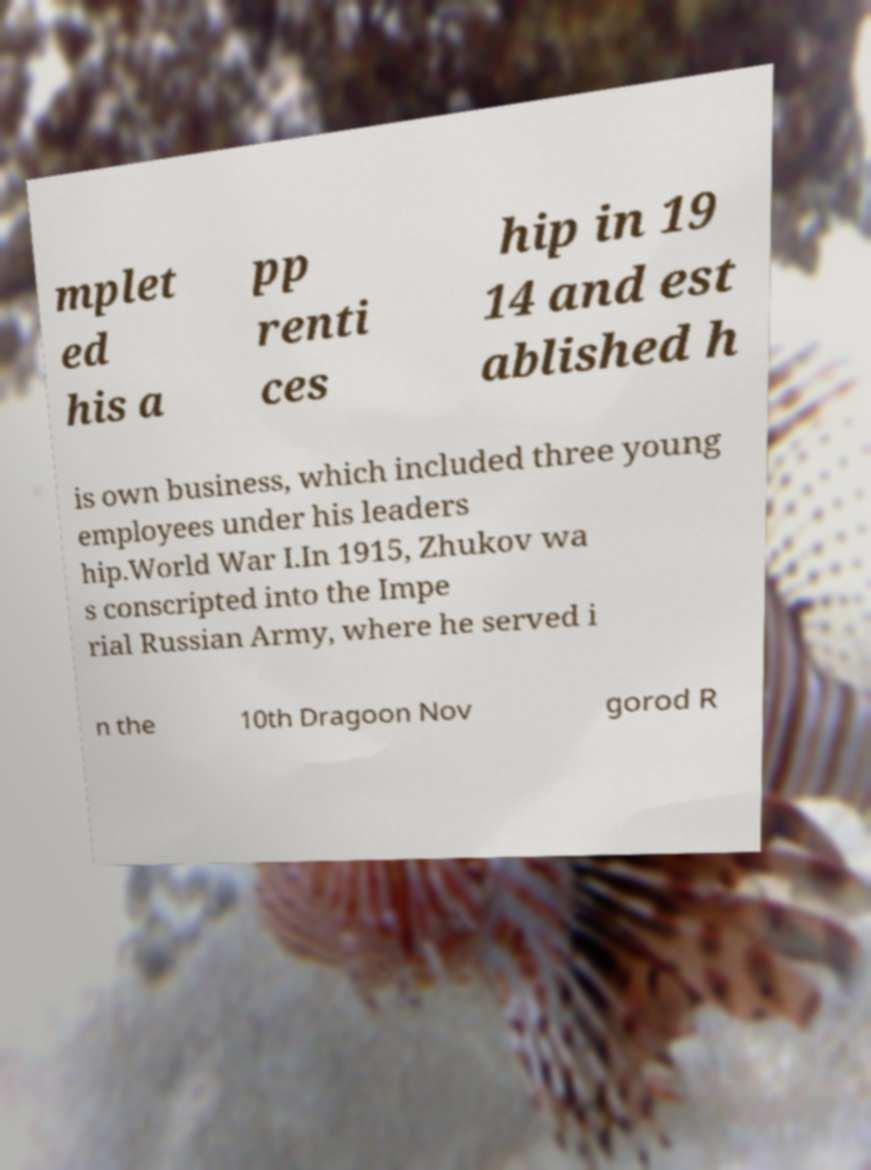Can you accurately transcribe the text from the provided image for me? mplet ed his a pp renti ces hip in 19 14 and est ablished h is own business, which included three young employees under his leaders hip.World War I.In 1915, Zhukov wa s conscripted into the Impe rial Russian Army, where he served i n the 10th Dragoon Nov gorod R 